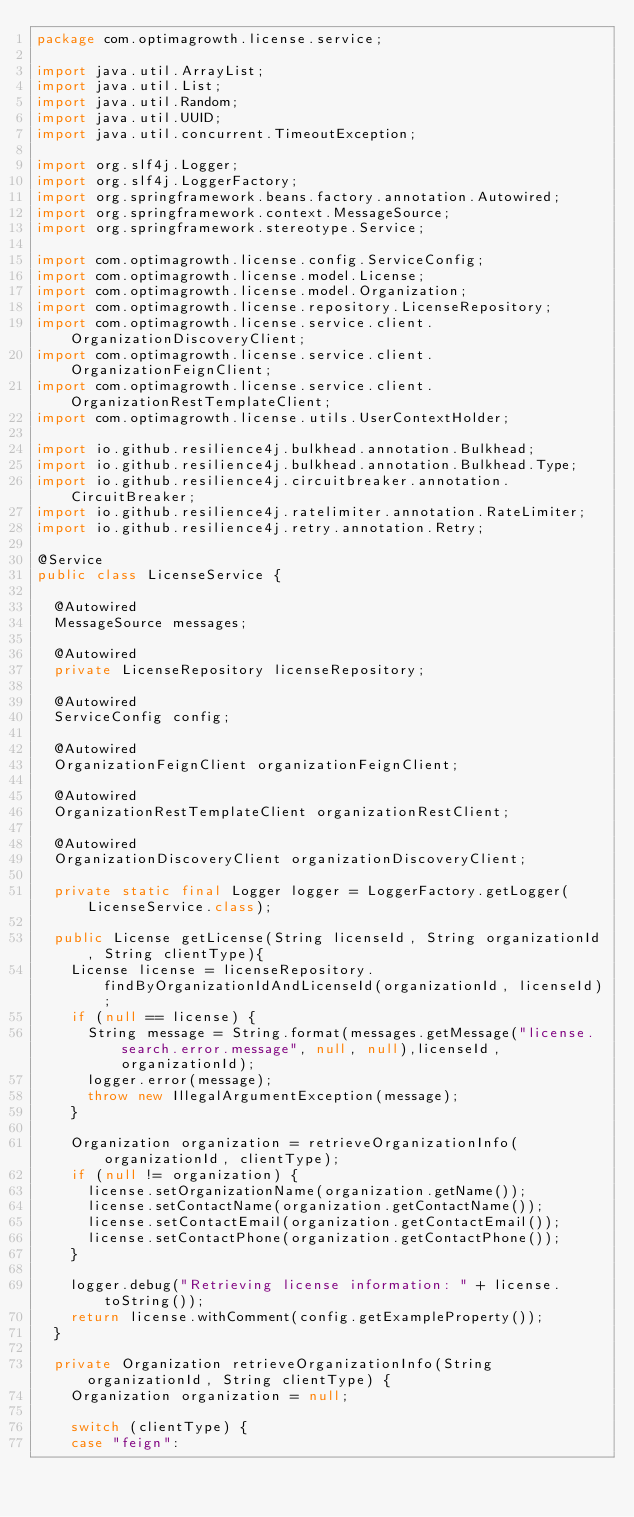Convert code to text. <code><loc_0><loc_0><loc_500><loc_500><_Java_>package com.optimagrowth.license.service;

import java.util.ArrayList;
import java.util.List;
import java.util.Random;
import java.util.UUID;
import java.util.concurrent.TimeoutException;

import org.slf4j.Logger;
import org.slf4j.LoggerFactory;
import org.springframework.beans.factory.annotation.Autowired;
import org.springframework.context.MessageSource;
import org.springframework.stereotype.Service;

import com.optimagrowth.license.config.ServiceConfig;
import com.optimagrowth.license.model.License;
import com.optimagrowth.license.model.Organization;
import com.optimagrowth.license.repository.LicenseRepository;
import com.optimagrowth.license.service.client.OrganizationDiscoveryClient;
import com.optimagrowth.license.service.client.OrganizationFeignClient;
import com.optimagrowth.license.service.client.OrganizationRestTemplateClient;
import com.optimagrowth.license.utils.UserContextHolder;

import io.github.resilience4j.bulkhead.annotation.Bulkhead;
import io.github.resilience4j.bulkhead.annotation.Bulkhead.Type;
import io.github.resilience4j.circuitbreaker.annotation.CircuitBreaker;
import io.github.resilience4j.ratelimiter.annotation.RateLimiter;
import io.github.resilience4j.retry.annotation.Retry;

@Service
public class LicenseService {

	@Autowired
	MessageSource messages;

	@Autowired
	private LicenseRepository licenseRepository;

	@Autowired
	ServiceConfig config;

	@Autowired
	OrganizationFeignClient organizationFeignClient;

	@Autowired
	OrganizationRestTemplateClient organizationRestClient;

	@Autowired
	OrganizationDiscoveryClient organizationDiscoveryClient;
	
	private static final Logger logger = LoggerFactory.getLogger(LicenseService.class);

	public License getLicense(String licenseId, String organizationId, String clientType){
		License license = licenseRepository.findByOrganizationIdAndLicenseId(organizationId, licenseId);
		if (null == license) {
			String message = String.format(messages.getMessage("license.search.error.message", null, null),licenseId, organizationId);
			logger.error(message);
			throw new IllegalArgumentException(message);	
		}

		Organization organization = retrieveOrganizationInfo(organizationId, clientType);
		if (null != organization) {
			license.setOrganizationName(organization.getName());
			license.setContactName(organization.getContactName());
			license.setContactEmail(organization.getContactEmail());
			license.setContactPhone(organization.getContactPhone());
		}

		logger.debug("Retrieving license information: " + license.toString());
		return license.withComment(config.getExampleProperty());
	}

	private Organization retrieveOrganizationInfo(String organizationId, String clientType) {
		Organization organization = null;

		switch (clientType) {
		case "feign":</code> 